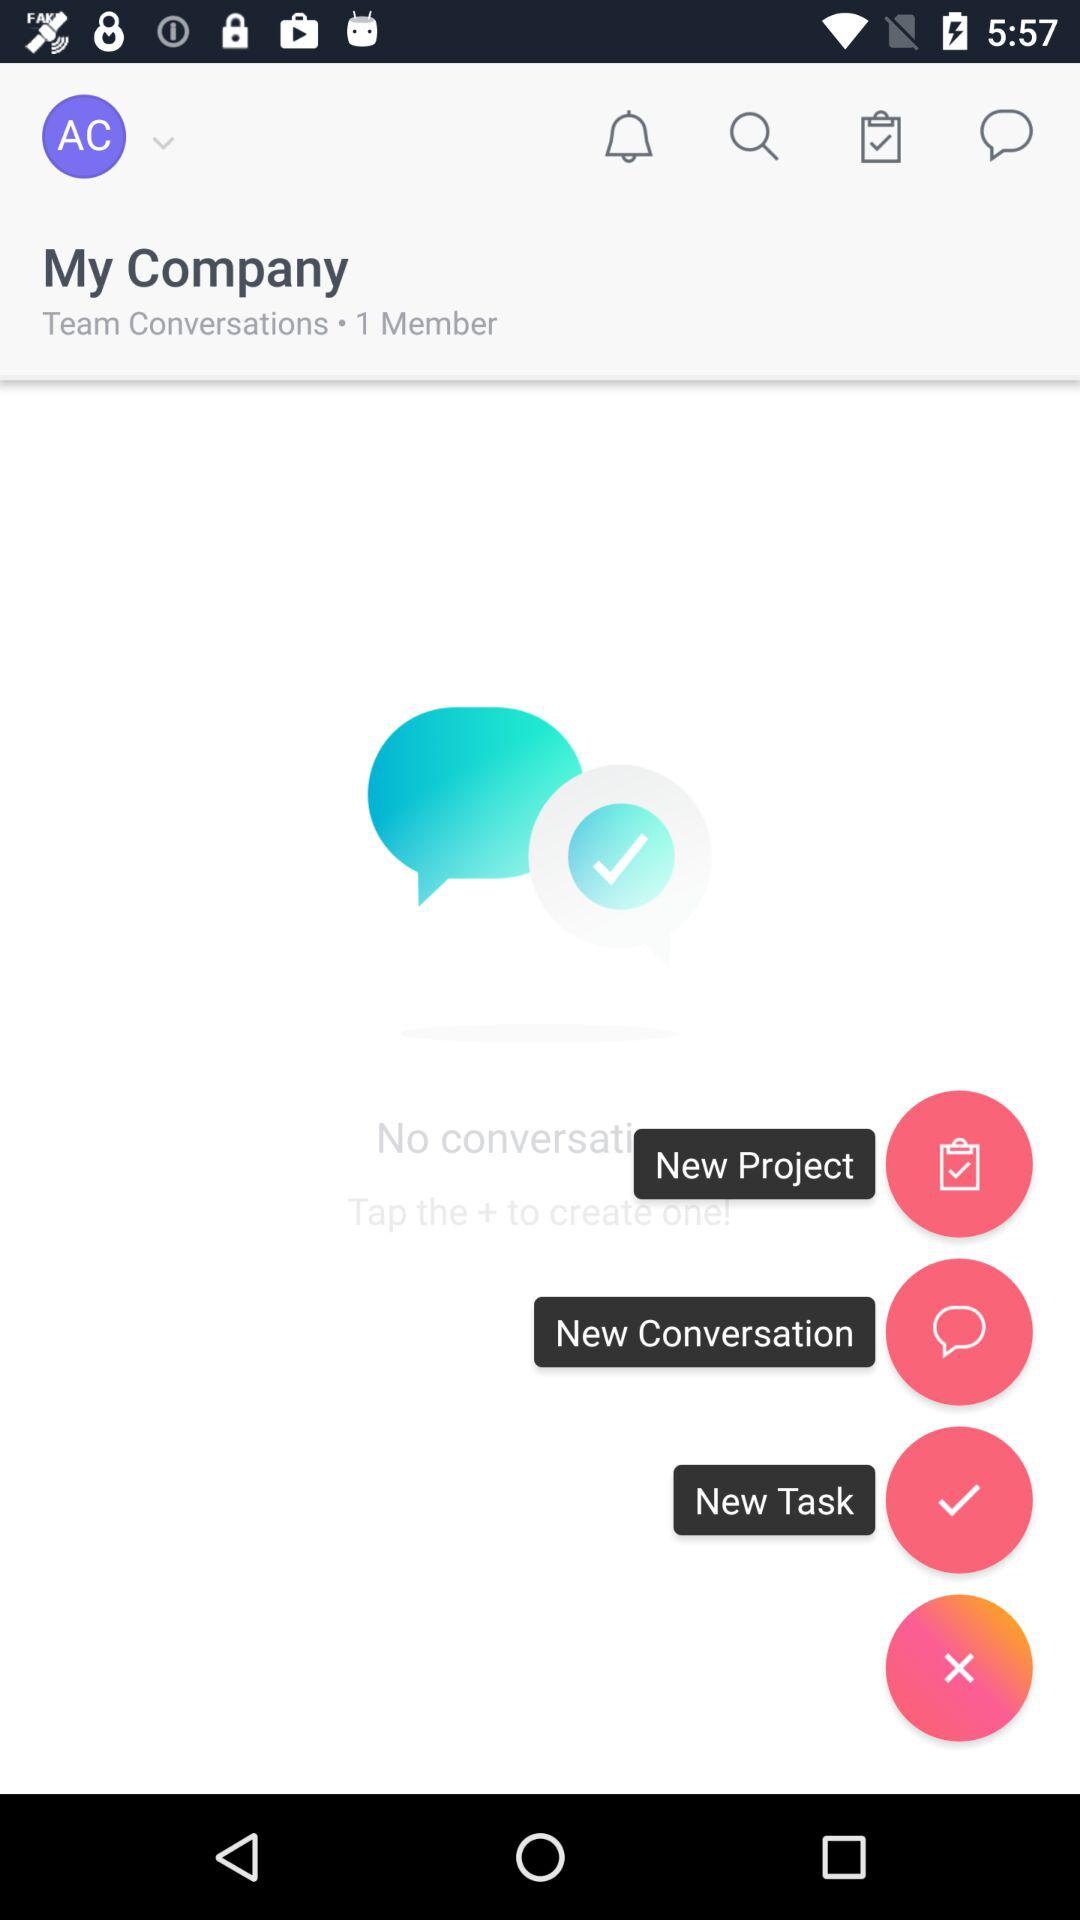How many members are in "Team Conversations"? There is only 1 member. 